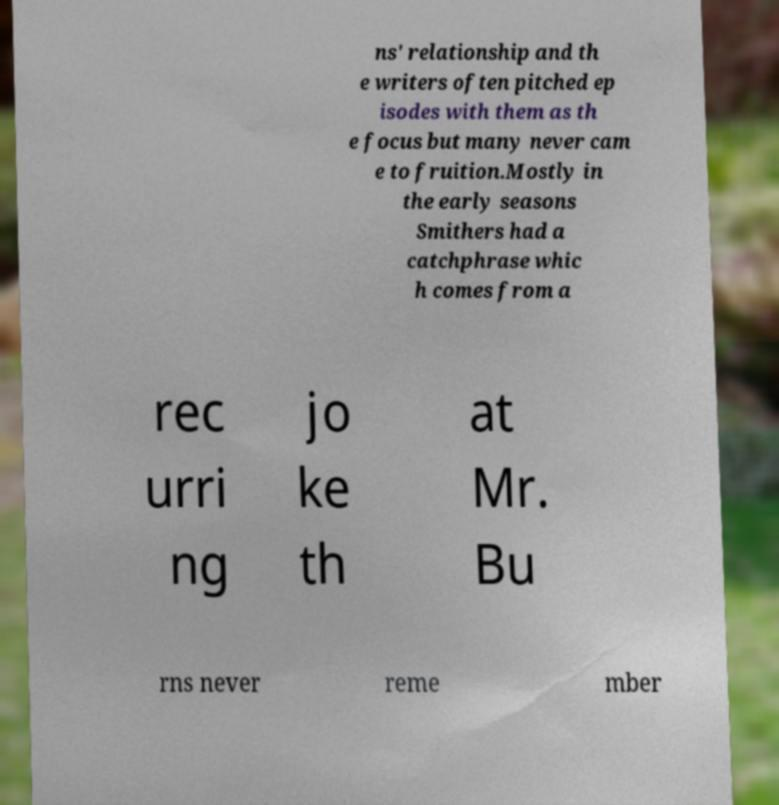Could you assist in decoding the text presented in this image and type it out clearly? ns' relationship and th e writers often pitched ep isodes with them as th e focus but many never cam e to fruition.Mostly in the early seasons Smithers had a catchphrase whic h comes from a rec urri ng jo ke th at Mr. Bu rns never reme mber 